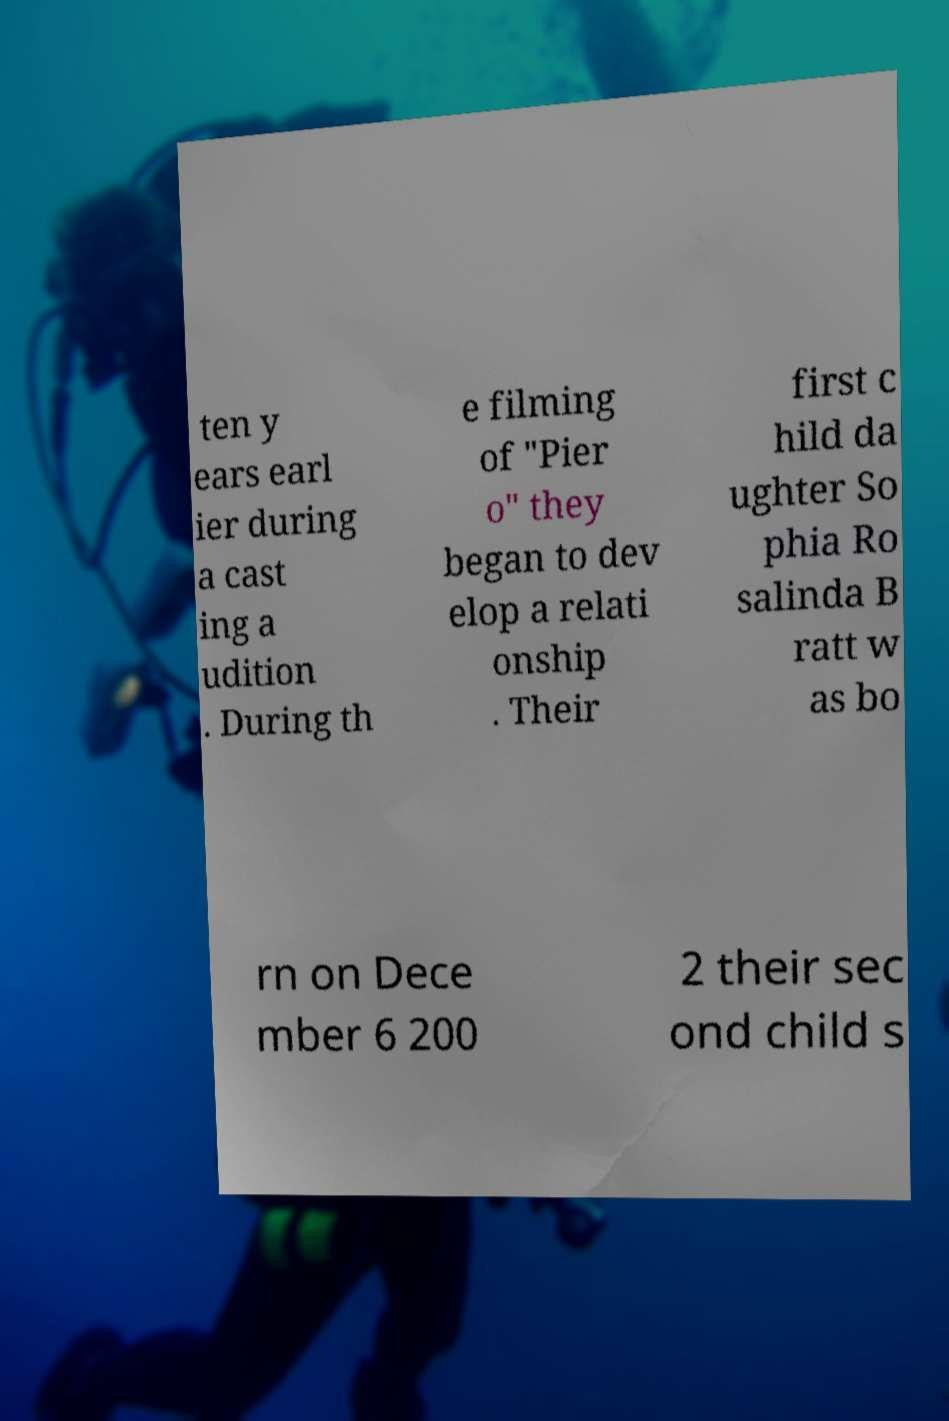Could you assist in decoding the text presented in this image and type it out clearly? ten y ears earl ier during a cast ing a udition . During th e filming of "Pier o" they began to dev elop a relati onship . Their first c hild da ughter So phia Ro salinda B ratt w as bo rn on Dece mber 6 200 2 their sec ond child s 